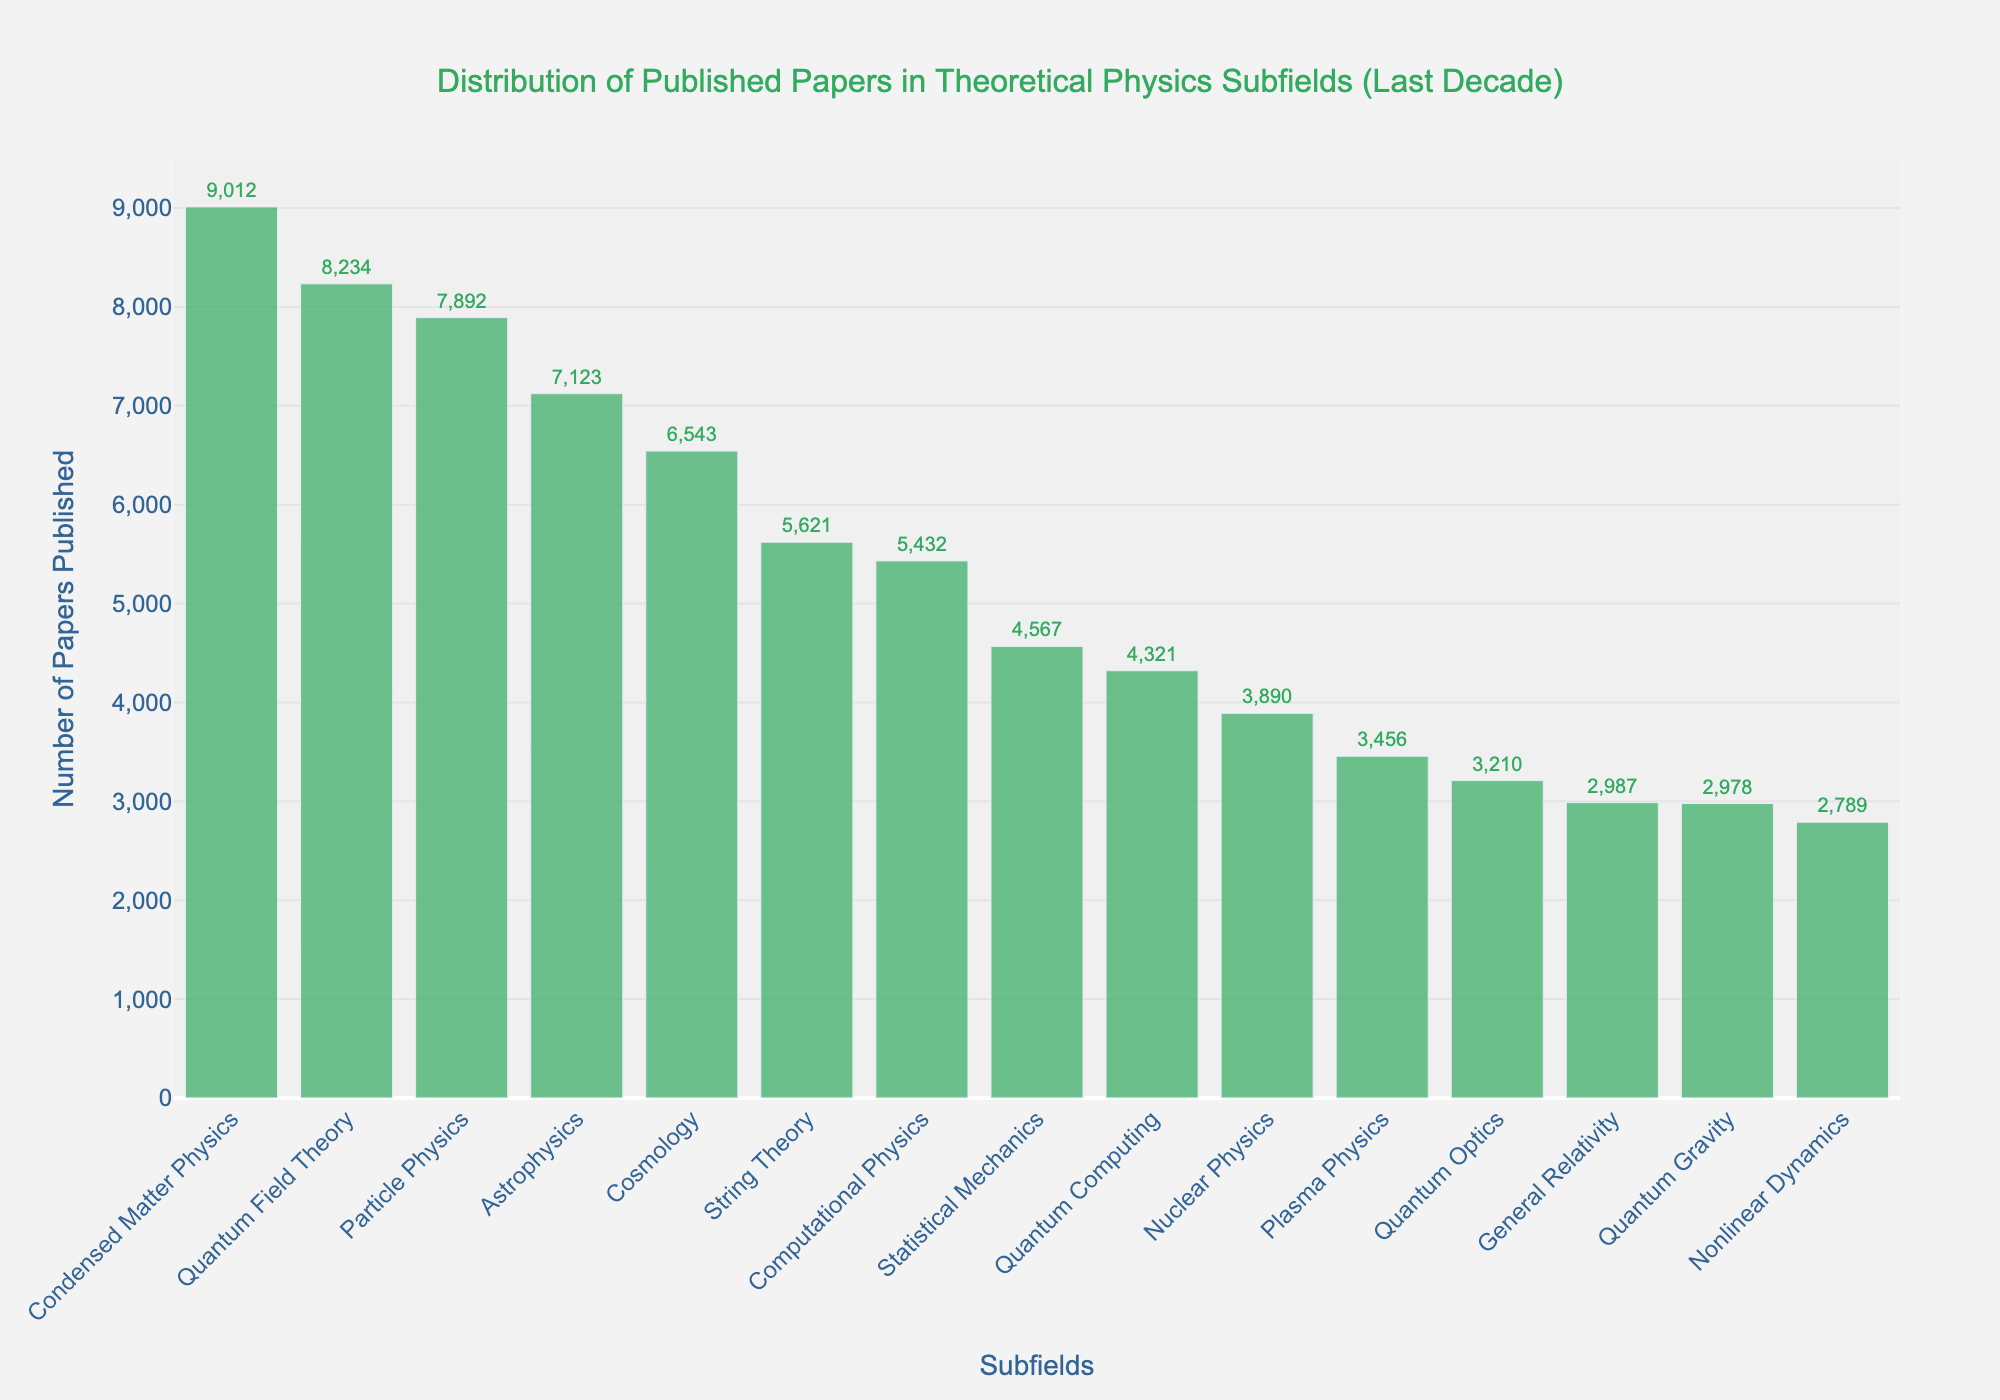Which subfield has the highest number of published papers? The subfield with the highest bar represents the highest number of published papers. By looking at the height of the bars, Condensed Matter Physics has the tallest bar.
Answer: Condensed Matter Physics Which subfield has the least number of published papers? The subfield with the shortest bar represents the least number of published papers. Quantum Optics has the shortest bar, thus it's the subfield with the least number of publications.
Answer: Nonlinear Dynamics How many more papers are published in Quantum Field Theory compared to Computational Physics? The number of papers published in Quantum Field Theory is 8234 and in Computational Physics is 5432. Therefore, the difference is 8234 - 5432 = 2802.
Answer: 2802 What is the combined number of papers published in Quantum Field Theory, Particle Physics, and Cosmology? Add the numbers for Quantum Field Theory (8234), Particle Physics (7892), and Cosmology (6543): 8234 + 7892 + 6543 = 22669.
Answer: 22669 Which subfield has more papers published, Astrophysics or Quantum Computing? By how many papers? Astrophysics has 7123 papers published while Quantum Computing has 4321. The difference is 7123 - 4321 = 2802.
Answer: Astrophysics, 2802 What is the average number of papers published across all subfields? Add all the papers published in each subfield and divide by the number of subfields: (8234 + 5621 + 7892 + 6543 + 9012 + 4567 + 3890 + 2978 + 5432 + 7123 + 4321 + 3456 + 2789 + 3210 + 2987) / 15 = 5625.
Answer: 5625 Compare the number of papers published in the top three subfields. What percentage of the total publications do they represent? The top three subfields are Condensed Matter Physics (9012), Quantum Field Theory (8234), and Particle Physics (7892). Their total is 9012 + 8234 + 7892 = 25138. The combined total of all papers published is 84330. The percentage is (25138 / 84330) * 100 = 29.8%.
Answer: 29.8% How many papers were published in subfields with less than 4000 papers? Which subfields are these? The subfields with less than 4000 papers are Nuclear Physics (3890), Quantum Gravity (2978), Plasma Physics (3456), Nonlinear Dynamics (2789), Quantum Optics (3210), and General Relativity (2987). The total is 3890 + 2978 + 3456 + 2789 + 3210 + 2987 = 19310.
Answer: 19310, Nuclear Physics, Quantum Gravity, Plasma Physics, Nonlinear Dynamics, Quantum Optics, General Relativity What is the range of the number of papers published across all subfields? The range is the difference between the highest and lowest number of published papers. Condensed Matter Physics has the highest (9012) and Nonlinear Dynamics has the lowest (2789). The range is 9012 - 2789 = 6223.
Answer: 6223 